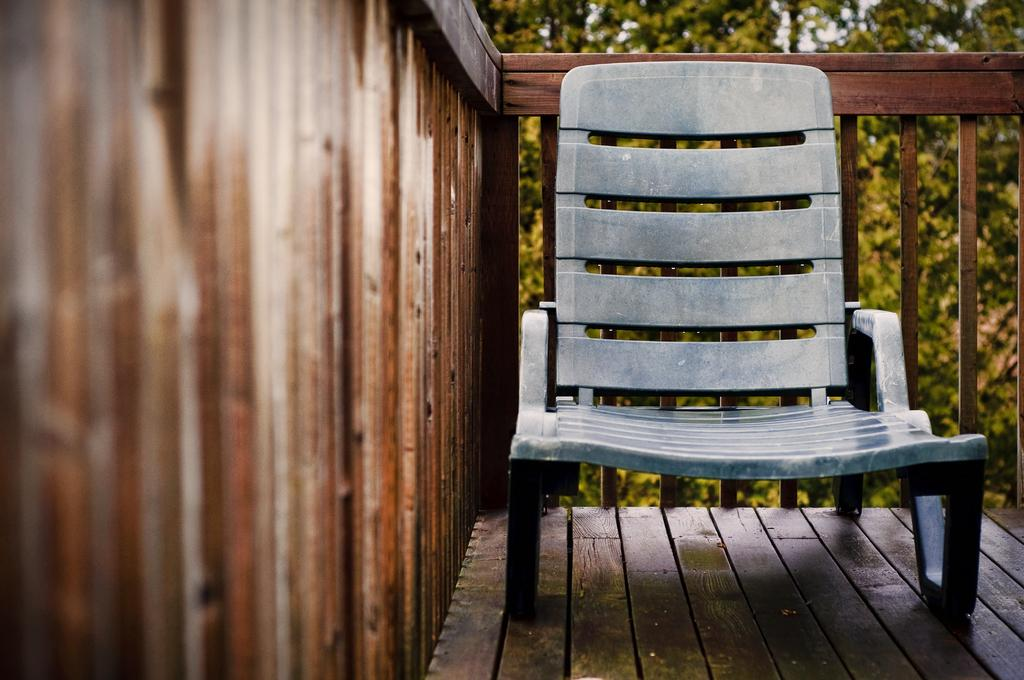What type of furniture is in the image? There is a chair in the image. What material is the chair made of? The chair appears to be made of wood. What else made of wood can be seen in the image? There is a wooden fence in the image. What is visible beneath the chair and fence? The floor is visible in the image. What can be seen in the distance behind the chair and fence? There are trees in the background of the image. What type of vegetable is being weighed on the scale in the image? There is no vegetable or scale present in the image. 